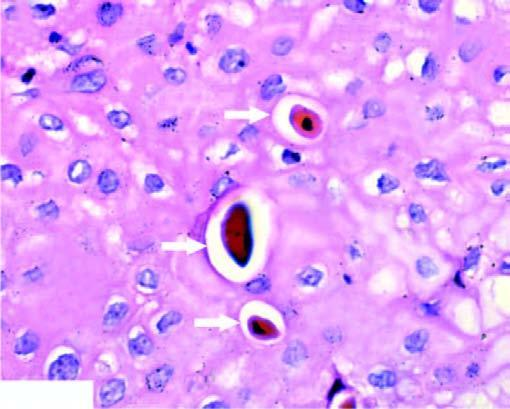what has the nucleus clumped?
Answer the question using a single word or phrase. Chromatin 